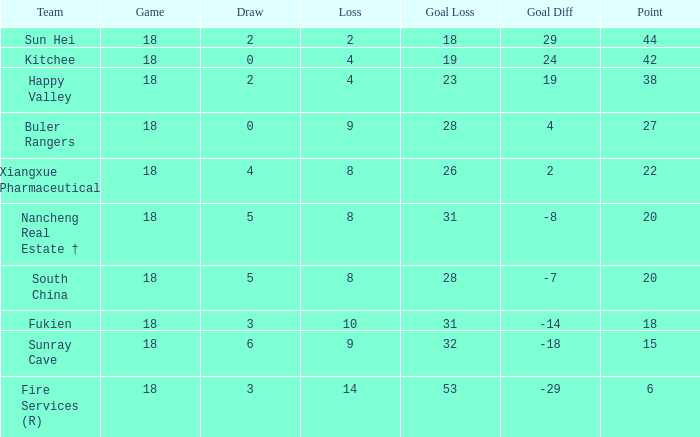What team with a Game smaller than 18 has the lowest Goal Gain? None. 